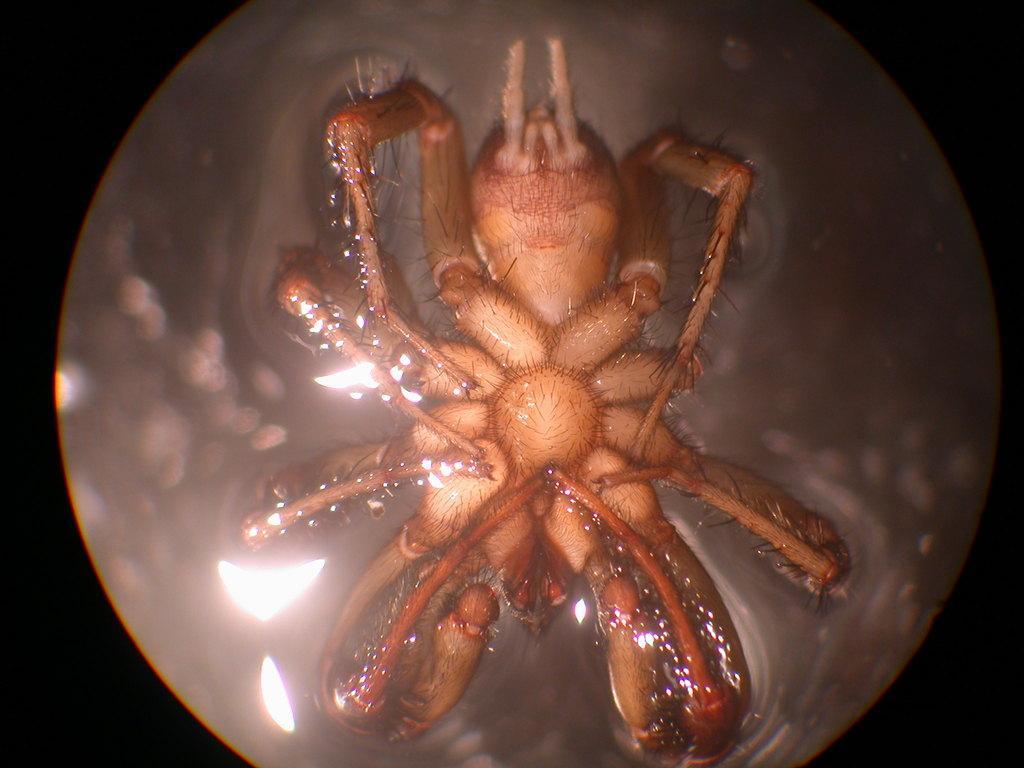In one or two sentences, can you explain what this image depicts? In this picture there is a spider in the water. 